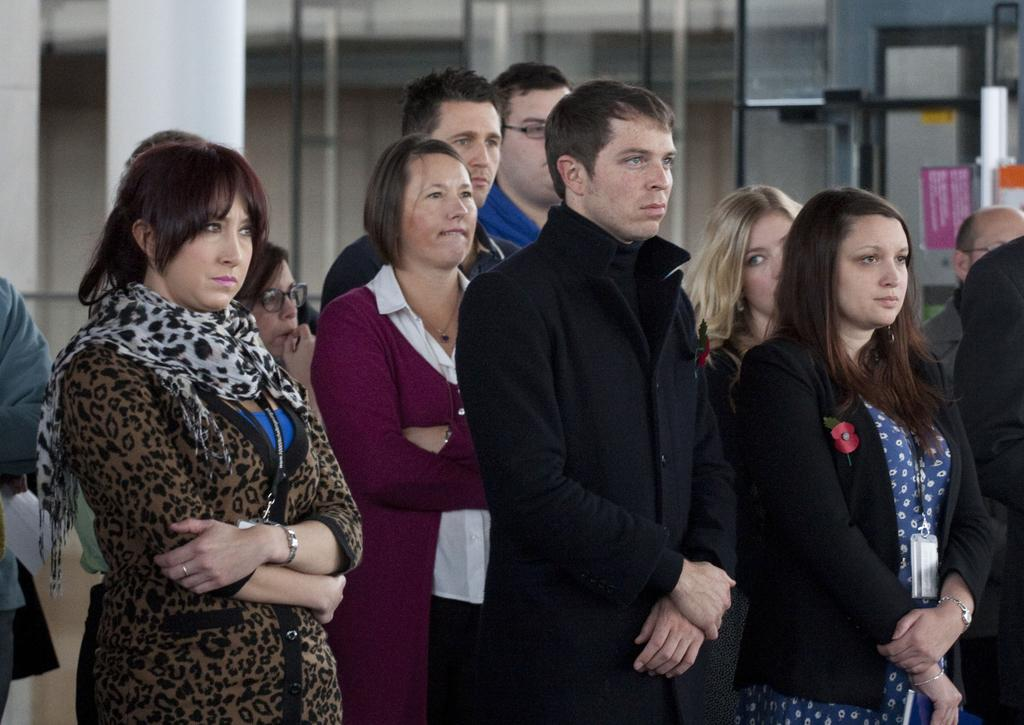What is the main subject of the image? The main subject of the image is a crowd of people. Where are the people located in the image? The people are standing on the ground. What can be seen in the background of the image? In the background of the image, there are windows, poles, and a mirror with paper sticked on it. What color is the crayon being used by the hen in the image? There is no hen or crayon present in the image. How many pipes are visible in the image? The provided facts do not mention any pipes in the image. 